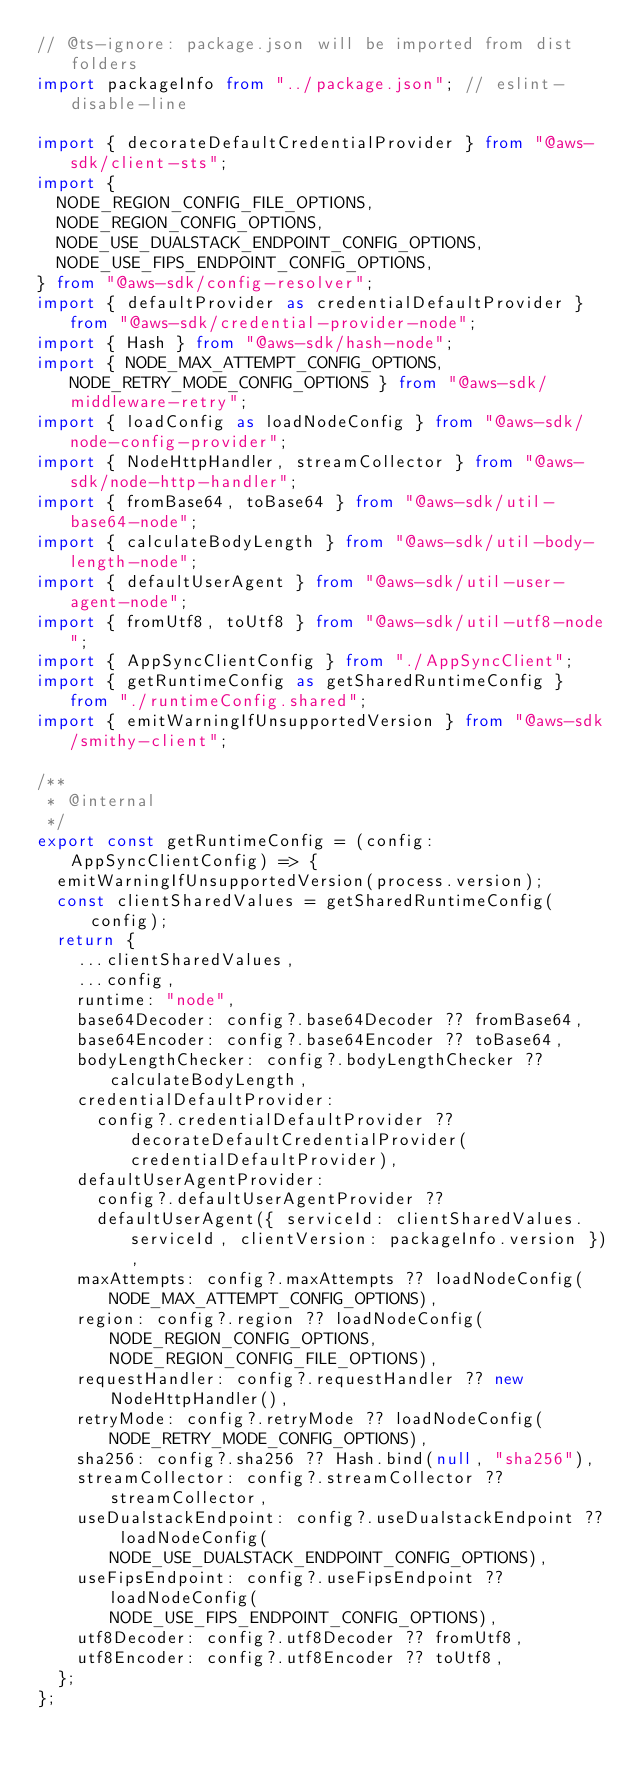Convert code to text. <code><loc_0><loc_0><loc_500><loc_500><_TypeScript_>// @ts-ignore: package.json will be imported from dist folders
import packageInfo from "../package.json"; // eslint-disable-line

import { decorateDefaultCredentialProvider } from "@aws-sdk/client-sts";
import {
  NODE_REGION_CONFIG_FILE_OPTIONS,
  NODE_REGION_CONFIG_OPTIONS,
  NODE_USE_DUALSTACK_ENDPOINT_CONFIG_OPTIONS,
  NODE_USE_FIPS_ENDPOINT_CONFIG_OPTIONS,
} from "@aws-sdk/config-resolver";
import { defaultProvider as credentialDefaultProvider } from "@aws-sdk/credential-provider-node";
import { Hash } from "@aws-sdk/hash-node";
import { NODE_MAX_ATTEMPT_CONFIG_OPTIONS, NODE_RETRY_MODE_CONFIG_OPTIONS } from "@aws-sdk/middleware-retry";
import { loadConfig as loadNodeConfig } from "@aws-sdk/node-config-provider";
import { NodeHttpHandler, streamCollector } from "@aws-sdk/node-http-handler";
import { fromBase64, toBase64 } from "@aws-sdk/util-base64-node";
import { calculateBodyLength } from "@aws-sdk/util-body-length-node";
import { defaultUserAgent } from "@aws-sdk/util-user-agent-node";
import { fromUtf8, toUtf8 } from "@aws-sdk/util-utf8-node";
import { AppSyncClientConfig } from "./AppSyncClient";
import { getRuntimeConfig as getSharedRuntimeConfig } from "./runtimeConfig.shared";
import { emitWarningIfUnsupportedVersion } from "@aws-sdk/smithy-client";

/**
 * @internal
 */
export const getRuntimeConfig = (config: AppSyncClientConfig) => {
  emitWarningIfUnsupportedVersion(process.version);
  const clientSharedValues = getSharedRuntimeConfig(config);
  return {
    ...clientSharedValues,
    ...config,
    runtime: "node",
    base64Decoder: config?.base64Decoder ?? fromBase64,
    base64Encoder: config?.base64Encoder ?? toBase64,
    bodyLengthChecker: config?.bodyLengthChecker ?? calculateBodyLength,
    credentialDefaultProvider:
      config?.credentialDefaultProvider ?? decorateDefaultCredentialProvider(credentialDefaultProvider),
    defaultUserAgentProvider:
      config?.defaultUserAgentProvider ??
      defaultUserAgent({ serviceId: clientSharedValues.serviceId, clientVersion: packageInfo.version }),
    maxAttempts: config?.maxAttempts ?? loadNodeConfig(NODE_MAX_ATTEMPT_CONFIG_OPTIONS),
    region: config?.region ?? loadNodeConfig(NODE_REGION_CONFIG_OPTIONS, NODE_REGION_CONFIG_FILE_OPTIONS),
    requestHandler: config?.requestHandler ?? new NodeHttpHandler(),
    retryMode: config?.retryMode ?? loadNodeConfig(NODE_RETRY_MODE_CONFIG_OPTIONS),
    sha256: config?.sha256 ?? Hash.bind(null, "sha256"),
    streamCollector: config?.streamCollector ?? streamCollector,
    useDualstackEndpoint: config?.useDualstackEndpoint ?? loadNodeConfig(NODE_USE_DUALSTACK_ENDPOINT_CONFIG_OPTIONS),
    useFipsEndpoint: config?.useFipsEndpoint ?? loadNodeConfig(NODE_USE_FIPS_ENDPOINT_CONFIG_OPTIONS),
    utf8Decoder: config?.utf8Decoder ?? fromUtf8,
    utf8Encoder: config?.utf8Encoder ?? toUtf8,
  };
};
</code> 